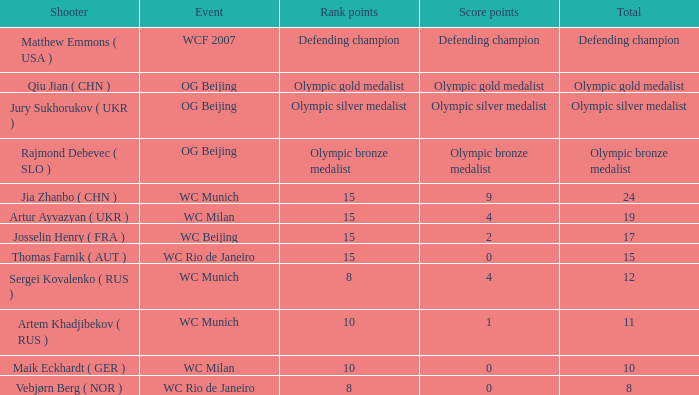With a combined 11, and 10 grade points, what are the points for the score? 1.0. 